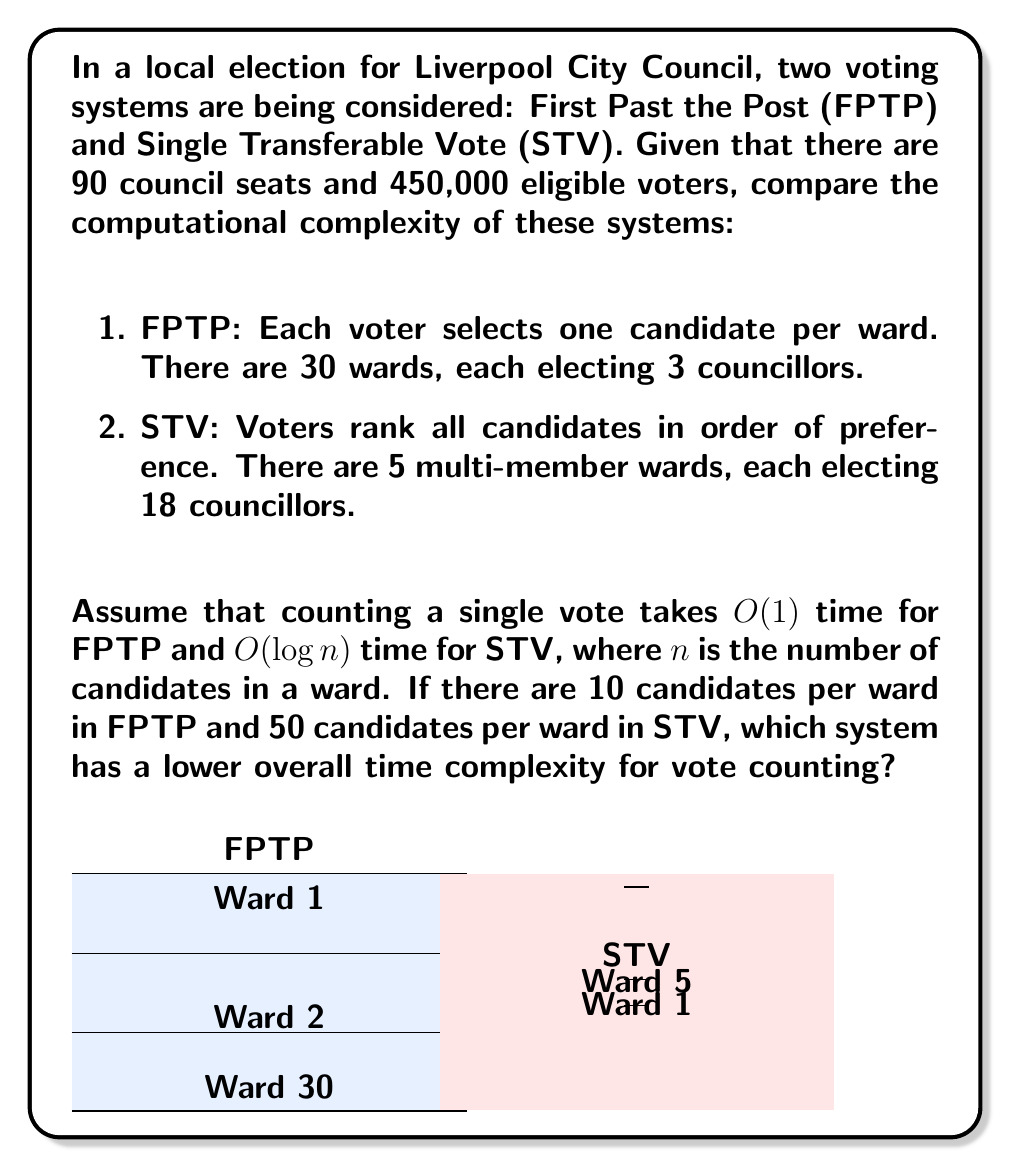Could you help me with this problem? Let's break down the problem step-by-step:

1. First Past the Post (FPTP):
   - Number of wards: 30
   - Voters per ward: 450,000 / 30 = 15,000
   - Time to count one vote: $O(1)$
   - Time complexity per ward: $O(15,000) = O(1) \cdot 15,000$
   - Total time complexity: $O(30 \cdot 15,000) = O(450,000)$

2. Single Transferable Vote (STV):
   - Number of wards: 5
   - Voters per ward: 450,000 / 5 = 90,000
   - Number of candidates per ward: 50
   - Time to count one vote: $O(\log n) = O(\log 50)$
   - Time complexity per ward: $O(90,000 \cdot \log 50)$
   - Total time complexity: $O(5 \cdot 90,000 \cdot \log 50) = O(450,000 \cdot \log 50)$

3. Comparing the two:
   FPTP: $O(450,000)$
   STV: $O(450,000 \cdot \log 50)$

   Since $\log 50 > 1$, the time complexity of STV is higher than FPTP.

4. To quantify the difference:
   $\log 50 \approx 5.64$ (using base 2 logarithm)

   So, STV is approximately 5.64 times slower than FPTP in terms of asymptotic time complexity.
Answer: FPTP has lower time complexity: $O(450,000)$ vs $O(450,000 \cdot \log 50)$ for STV. 